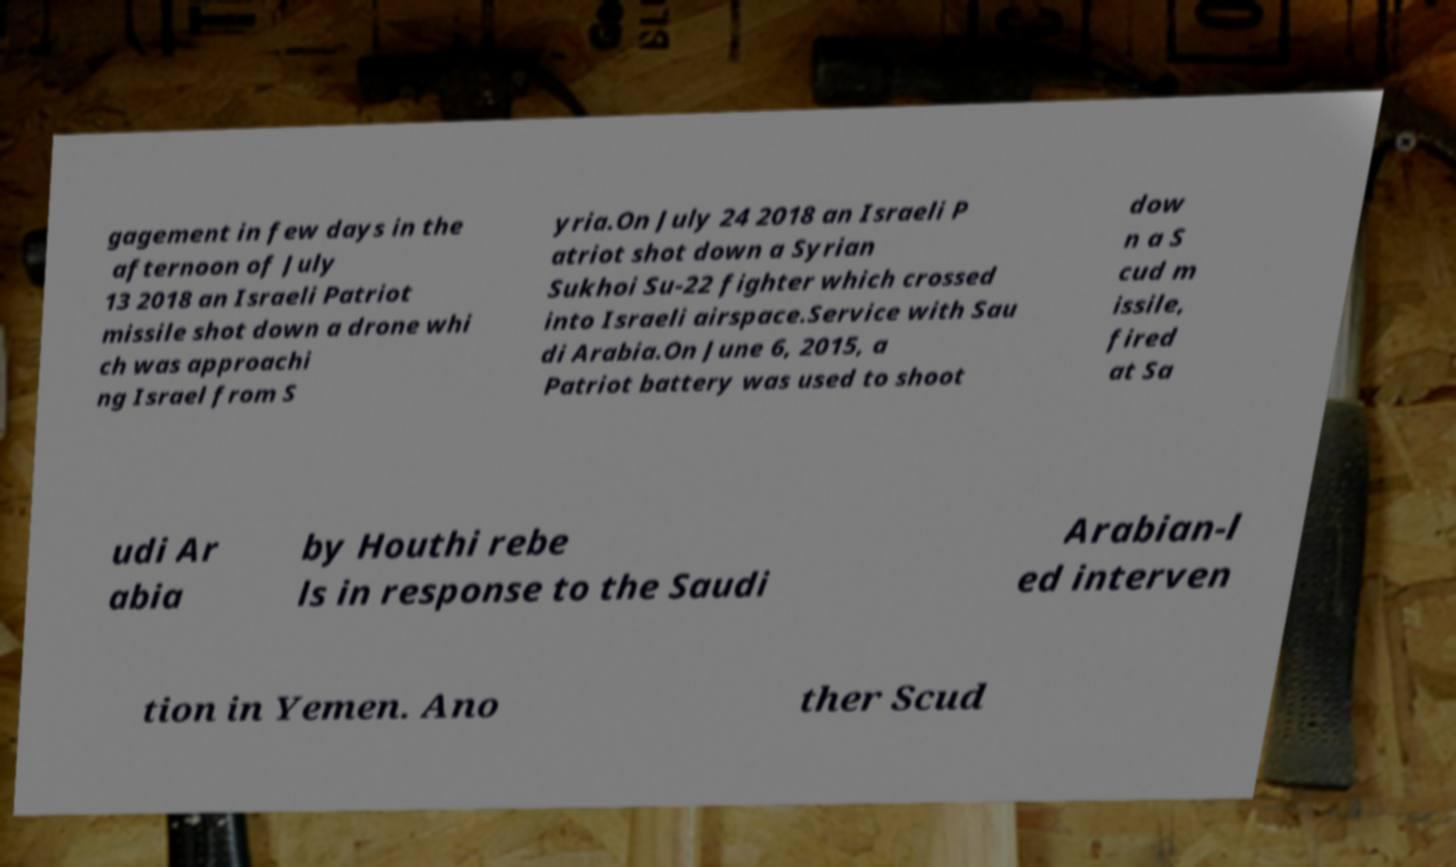For documentation purposes, I need the text within this image transcribed. Could you provide that? gagement in few days in the afternoon of July 13 2018 an Israeli Patriot missile shot down a drone whi ch was approachi ng Israel from S yria.On July 24 2018 an Israeli P atriot shot down a Syrian Sukhoi Su-22 fighter which crossed into Israeli airspace.Service with Sau di Arabia.On June 6, 2015, a Patriot battery was used to shoot dow n a S cud m issile, fired at Sa udi Ar abia by Houthi rebe ls in response to the Saudi Arabian-l ed interven tion in Yemen. Ano ther Scud 